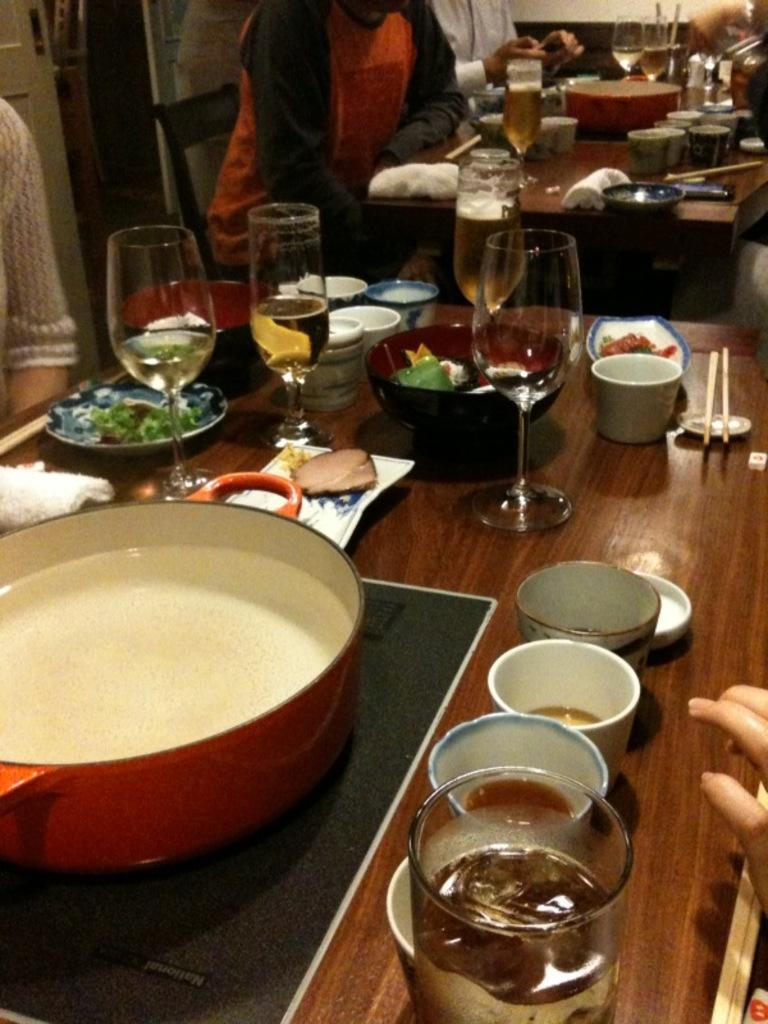What type of establishment is the image taken in? The image is taken in a restaurant. What items can be seen on the tables in the image? There are glasses and bowls on the tables in the image. How many persons are sitting in chairs to the left in the image? There are three persons sitting in chairs to the left in the image. What type of tree is growing in the middle of the restaurant in the image? There is no tree growing in the middle of the restaurant in the image. How many cakes are being served to the persons sitting in chairs to the left in the image? There is no information about cakes being served in the image. 